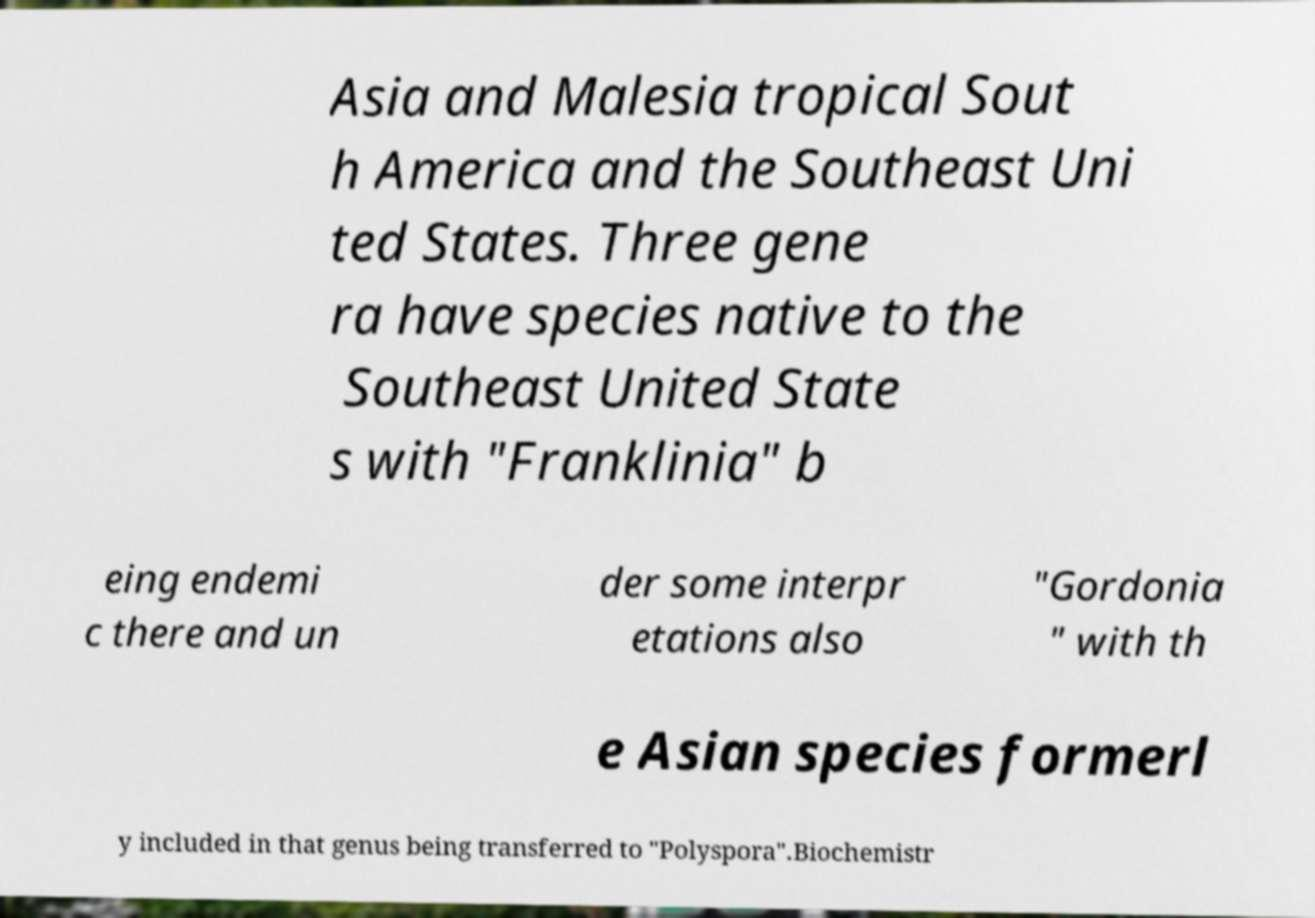There's text embedded in this image that I need extracted. Can you transcribe it verbatim? Asia and Malesia tropical Sout h America and the Southeast Uni ted States. Three gene ra have species native to the Southeast United State s with "Franklinia" b eing endemi c there and un der some interpr etations also "Gordonia " with th e Asian species formerl y included in that genus being transferred to "Polyspora".Biochemistr 